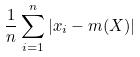Convert formula to latex. <formula><loc_0><loc_0><loc_500><loc_500>\frac { 1 } { n } \sum _ { i = 1 } ^ { n } | x _ { i } - m ( X ) |</formula> 